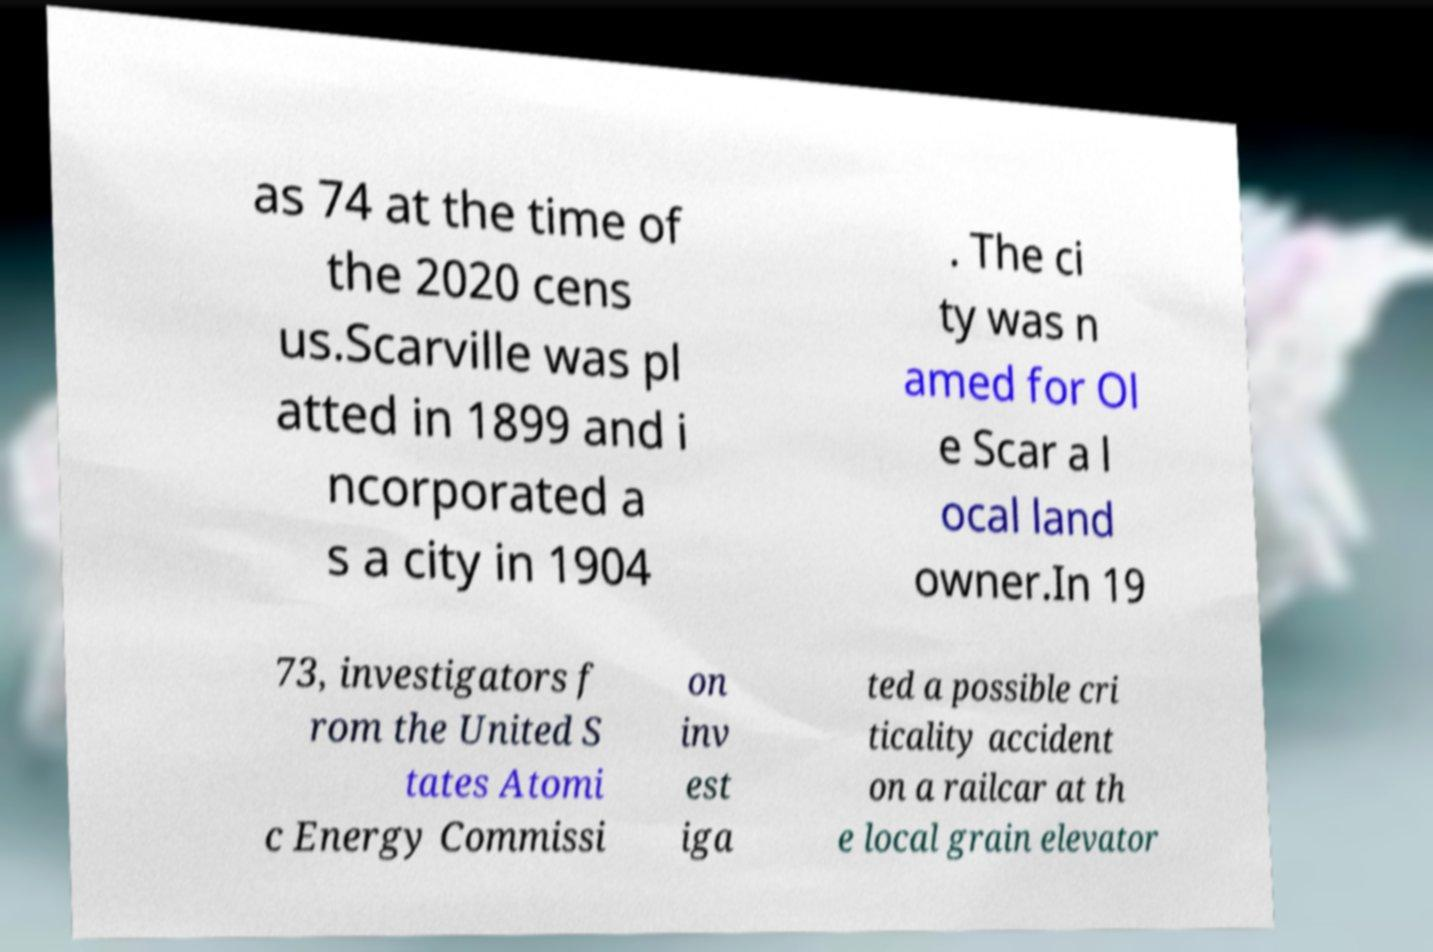Can you accurately transcribe the text from the provided image for me? as 74 at the time of the 2020 cens us.Scarville was pl atted in 1899 and i ncorporated a s a city in 1904 . The ci ty was n amed for Ol e Scar a l ocal land owner.In 19 73, investigators f rom the United S tates Atomi c Energy Commissi on inv est iga ted a possible cri ticality accident on a railcar at th e local grain elevator 